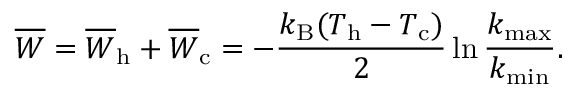Convert formula to latex. <formula><loc_0><loc_0><loc_500><loc_500>\overline { W } = \overline { W } _ { h } + \overline { W } _ { c } = - \frac { k _ { B } ( T _ { h } - T _ { c } ) } { 2 } \ln \frac { k _ { \max } } { k _ { \min } } .</formula> 